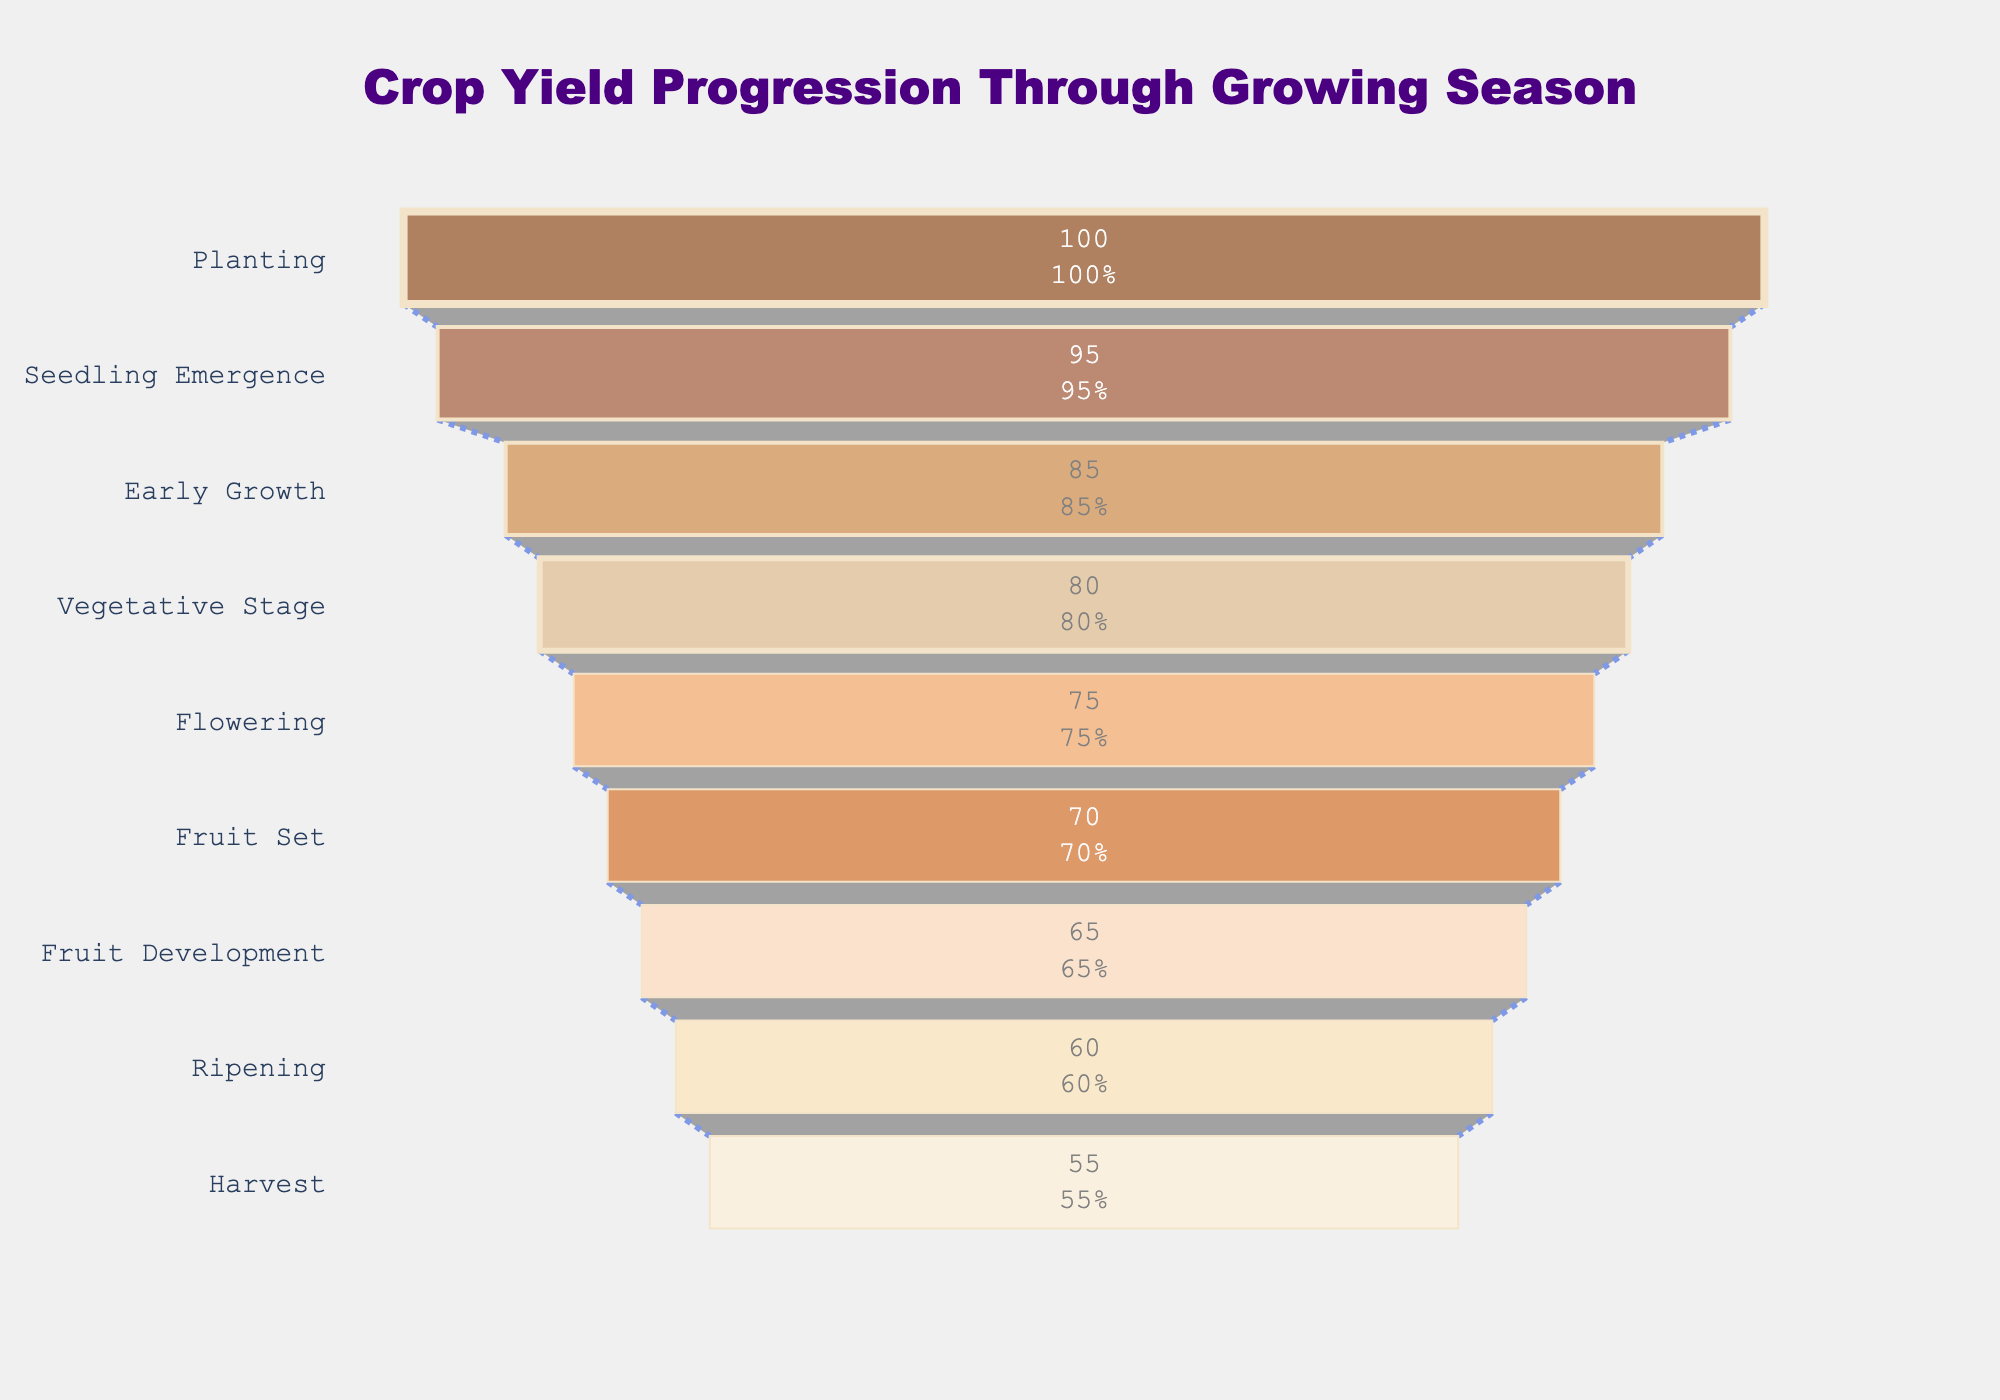How many stages are depicted in the funnel chart? The stages depicted in the funnel chart are represented by the distinct horizontal bands.
Answer: 9 What is the title of the chart shown? The title is explicitly mentioned at the top of the chart, highlighted in a larger, bold font.
Answer: Crop Yield Progression Through Growing Season Which stage has the highest percentage? The highest percentage corresponds to the widest part of the funnel at the top.
Answer: Planting By how much percent does the crop yield decrease from Planting to Harvest? Subtract the percentage at Harvest (55%) from the percentage at Planting (100%).
Answer: 45% What is the percentage at the Flowering stage? The Flowering stage percentage is shown inside the funnel section labeled "Flowering."
Answer: 75% During which stage does the first significant drop (more than 5%) in percentage occur? Compare consecutive percentages and identify the first drop greater than 5%. The drop occurs from Seedling Emergence (95%) to Early Growth (85%).
Answer: Early Growth What colors are used for the stages in the plot? Observe the different colors used in each section of the funnel, ranging in gradient from darker browns to lighter shades.
Answer: Various shades of brown to beige What is the average percentage of the stages involved from Seedling Emergence to Ripening? Sum the percentages from Seedling Emergence to Ripening and divide by 8. (95 + 85 + 80 + 75 + 70 + 65 + 60)/8 = 66.25
Answer: 66.25% Which stage immediately follows the Vegetative Stage and what is its percentage? Identify the stage listed after the Vegetative Stage in the funnel and note the associated percentage.
Answer: Flowering, 75% How many stages show a percentage equal to or below 70%? Count the stages where the percentage value is 70% or less. There are 4 such stages: Fruit Set (70%), Fruit Development (65%), Ripening (60%), and Harvest (55%).
Answer: 4 